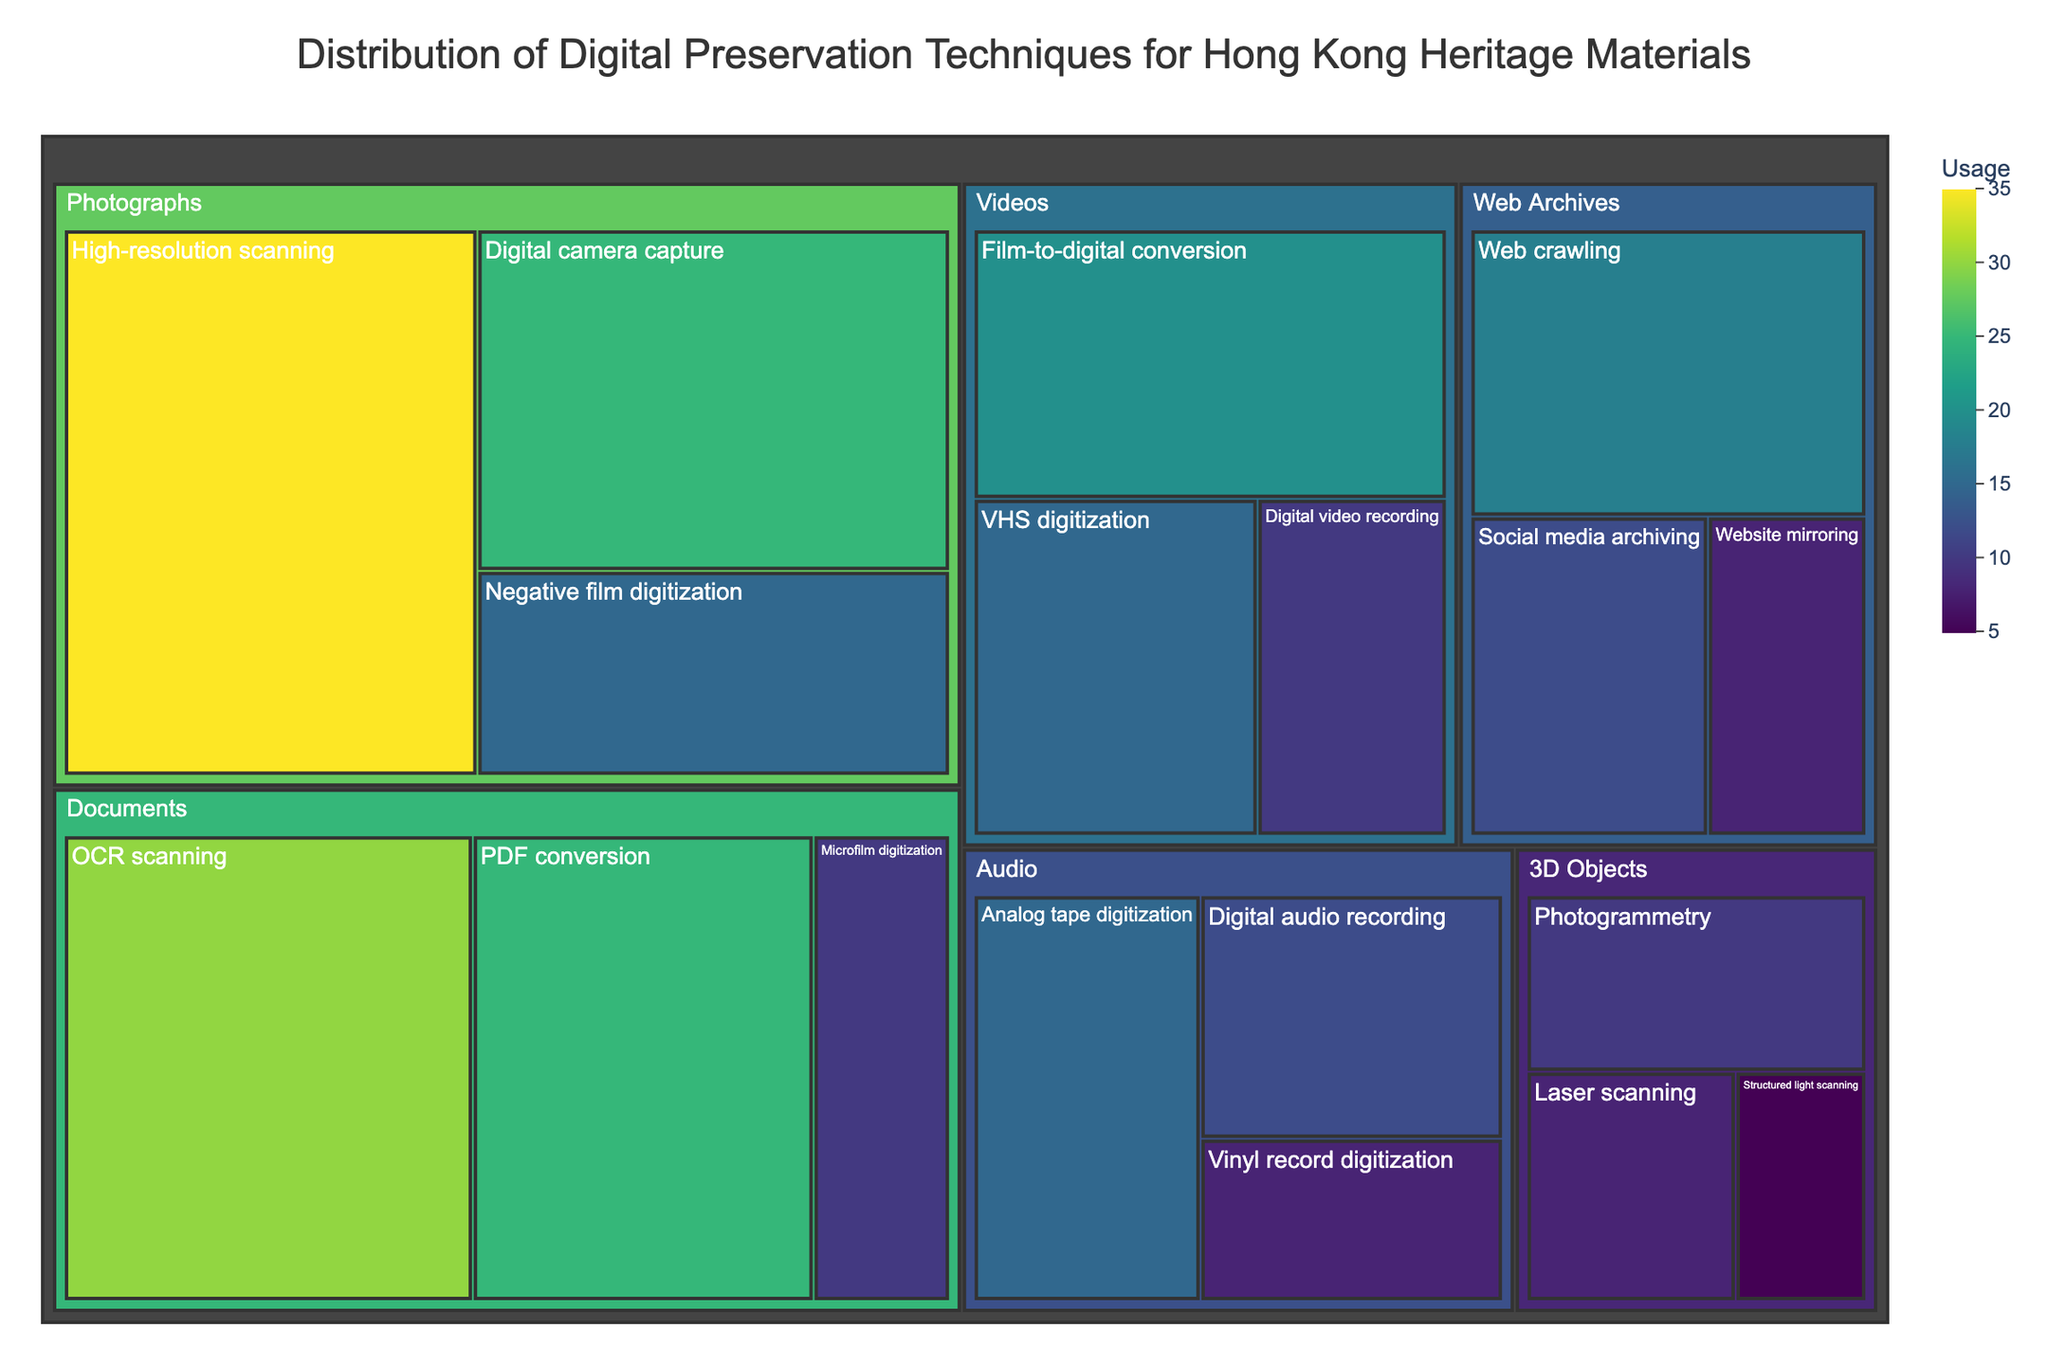What's the title of the treemap? The title of the treemap is displayed at the top of the figure, meant to describe the overall content.
Answer: Distribution of Digital Preservation Techniques for Hong Kong Heritage Materials Which preservation technique is used the most for photographs? By observing the size of the rectangles in the "Photographs" category, the largest one indicates the most-used technique. The "High-resolution scanning" rectangle is the largest.
Answer: High-resolution scanning What is the total usage of preservation techniques for videos? Adding up the usage values for "Film-to-digital conversion", "VHS digitization", and "Digital video recording" under the "Videos" category: 20 + 15 + 10.
Answer: 45 Which category has the highest usage of a single preservation technique, and what is that technique? Among the categories, we identify the largest single rectangle. "High-resolution scanning" in the "Photographs" category is the largest with a usage of 35.
Answer: Photographs, High-resolution scanning Compare the usage of "OCR scanning" and "PDF conversion" for documents. Which one is higher and by how much? Compare the sizes of the rectangles for "OCR scanning" and "PDF conversion" in the "Documents" category. "OCR scanning" has a usage of 30, and "PDF conversion" has 25. The difference is 30 - 25.
Answer: OCR scanning, 5 What is the combined usage of all techniques under the "Web Archives" category? Sum the usage values for "Web crawling", "Social media archiving", and "Website mirroring": 18 + 12 + 8.
Answer: 38 Among "Analog tape digitization", "Vinyl record digitization", and "Digital audio recording" for audio preservation, which has the lowest usage? By comparing the sizes of the rectangles in the "Audio" category, the smallest rectangle indicates the lowest usage. "Vinyl record digitization" has the lowest usage at 8.
Answer: Vinyl record digitization How does the usage of "Photogrammetry" compare to "Structured light scanning" for 3D objects? Compare the sizes of the rectangles for "Photogrammetry" and "Structured light scanning" in the "3D Objects" category. "Photogrammetry" has a usage of 10, and "Structured light scanning" has 5. "Photogrammetry" is higher by 10 - 5.
Answer: Photogrammetry, 5 What percentage of the total usage for "Documents" is contributed by "Microfilm digitization"? Add up the usage values for all techniques under "Documents": 30 (OCR scanning) + 25 (PDF conversion) + 10 (Microfilm digitization) = 65. Calculate the percentage for "Microfilm digitization": (10 / 65) * 100.
Answer: ~15.38% Which preservation technique within "3D Objects" has the second highest usage? By examining the sizes of the rectangles within the "3D Objects" category, identify the second largest. "Laser scanning" is second highest with a usage of 8 after "Photogrammetry" which has 10.
Answer: Laser scanning 